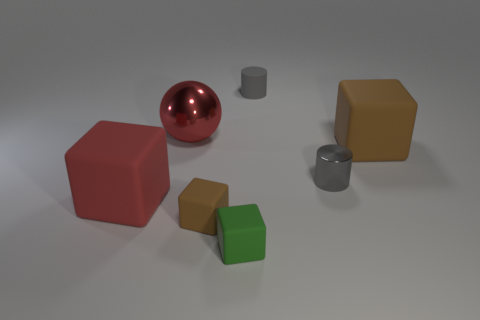What textures can you identify on the objects presented? Of the visible objects, the two gray cylinders and the red sphere exhibit smooth and shiny textures, indicative of materials like plastic or polished metal. The colored cubes have a matte finish, suggesting a more diffuse reflection consistent with objects made of materials like painted wood or matte plastic. 